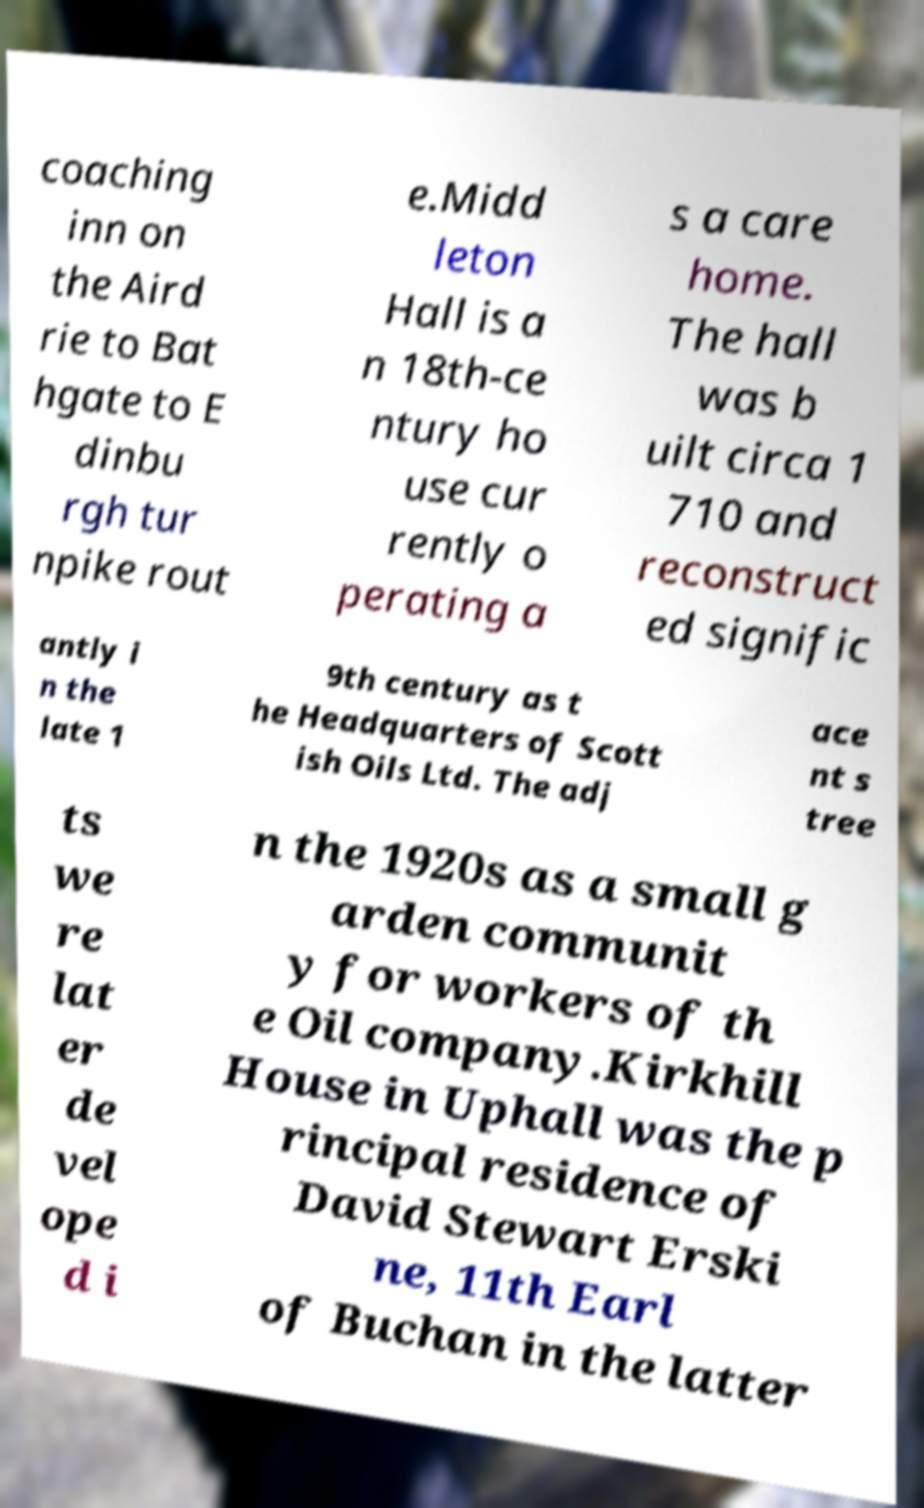What messages or text are displayed in this image? I need them in a readable, typed format. coaching inn on the Aird rie to Bat hgate to E dinbu rgh tur npike rout e.Midd leton Hall is a n 18th-ce ntury ho use cur rently o perating a s a care home. The hall was b uilt circa 1 710 and reconstruct ed signific antly i n the late 1 9th century as t he Headquarters of Scott ish Oils Ltd. The adj ace nt s tree ts we re lat er de vel ope d i n the 1920s as a small g arden communit y for workers of th e Oil company.Kirkhill House in Uphall was the p rincipal residence of David Stewart Erski ne, 11th Earl of Buchan in the latter 